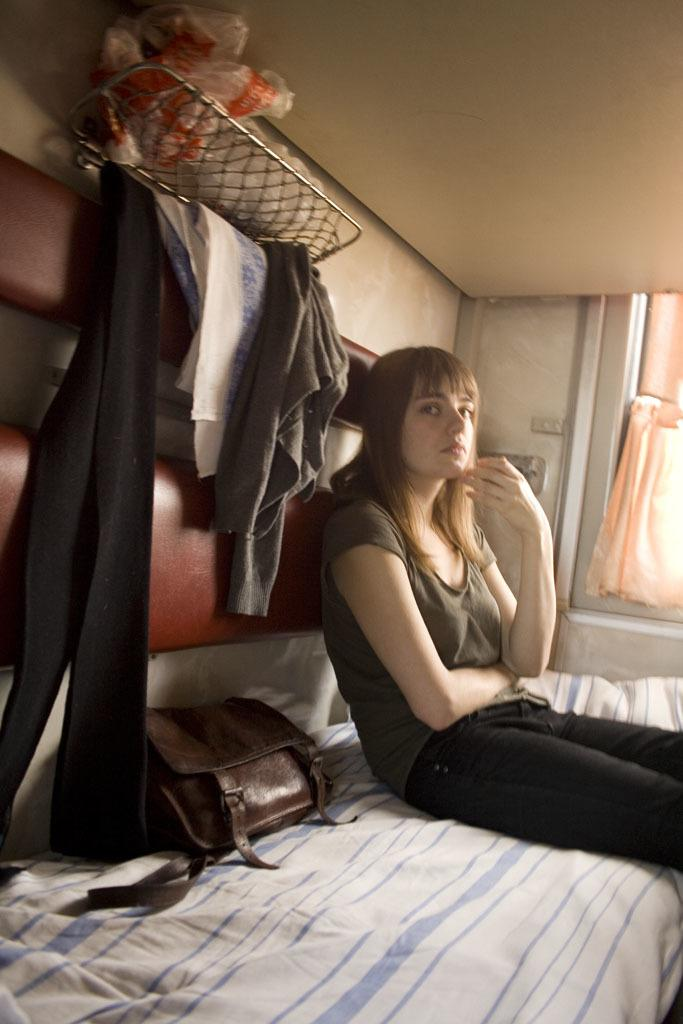What is the woman in the image doing? The woman is sitting on a bed in the image. What object can be seen near the woman? There is a handbag in the image. What type of clothing is hanging on a stand in the image? There are jackets hanging on a stand in the image. What is covering the bed or other furniture in the image? There is a plastic cover in the image. What can be seen in the background of the image? There is a window with curtains in the image. What type of business is being conducted in the image? There is no indication of any business being conducted in the image. What is the taste of the curtains in the image? The taste of the curtains cannot be determined, as they are not edible objects. 